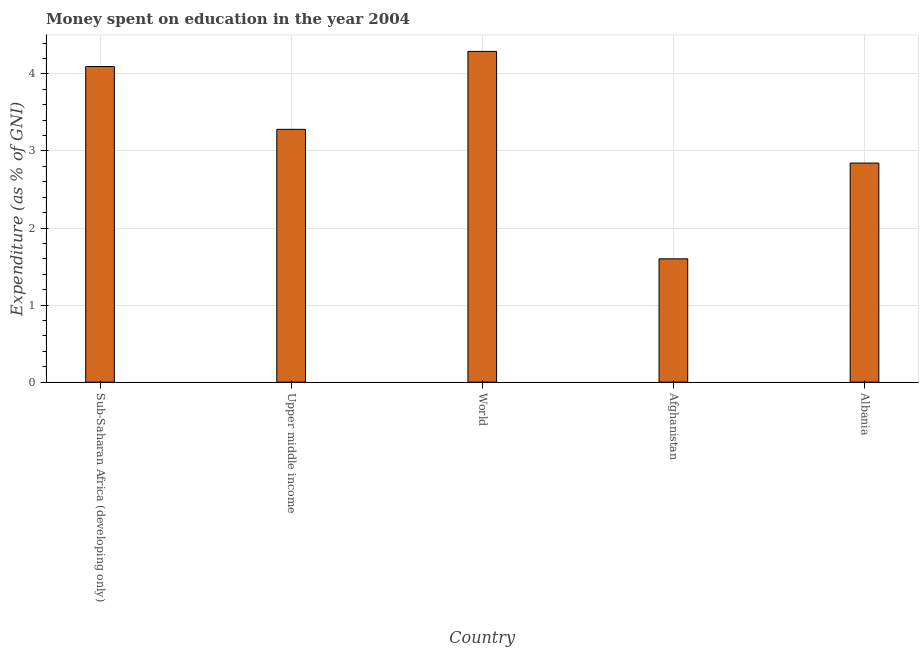What is the title of the graph?
Provide a short and direct response. Money spent on education in the year 2004. What is the label or title of the Y-axis?
Provide a short and direct response. Expenditure (as % of GNI). What is the expenditure on education in Upper middle income?
Give a very brief answer. 3.28. Across all countries, what is the maximum expenditure on education?
Provide a short and direct response. 4.29. In which country was the expenditure on education maximum?
Make the answer very short. World. In which country was the expenditure on education minimum?
Offer a very short reply. Afghanistan. What is the sum of the expenditure on education?
Keep it short and to the point. 16.11. What is the difference between the expenditure on education in Albania and Upper middle income?
Provide a short and direct response. -0.44. What is the average expenditure on education per country?
Your response must be concise. 3.22. What is the median expenditure on education?
Offer a terse response. 3.28. What is the ratio of the expenditure on education in Albania to that in World?
Offer a terse response. 0.66. Is the expenditure on education in Afghanistan less than that in Upper middle income?
Give a very brief answer. Yes. What is the difference between the highest and the second highest expenditure on education?
Make the answer very short. 0.2. Is the sum of the expenditure on education in Albania and Sub-Saharan Africa (developing only) greater than the maximum expenditure on education across all countries?
Make the answer very short. Yes. What is the difference between the highest and the lowest expenditure on education?
Keep it short and to the point. 2.69. In how many countries, is the expenditure on education greater than the average expenditure on education taken over all countries?
Your answer should be compact. 3. How many bars are there?
Your answer should be compact. 5. Are all the bars in the graph horizontal?
Give a very brief answer. No. Are the values on the major ticks of Y-axis written in scientific E-notation?
Provide a short and direct response. No. What is the Expenditure (as % of GNI) of Sub-Saharan Africa (developing only)?
Your answer should be very brief. 4.1. What is the Expenditure (as % of GNI) of Upper middle income?
Offer a terse response. 3.28. What is the Expenditure (as % of GNI) of World?
Make the answer very short. 4.29. What is the Expenditure (as % of GNI) of Albania?
Offer a very short reply. 2.84. What is the difference between the Expenditure (as % of GNI) in Sub-Saharan Africa (developing only) and Upper middle income?
Provide a short and direct response. 0.82. What is the difference between the Expenditure (as % of GNI) in Sub-Saharan Africa (developing only) and World?
Your answer should be compact. -0.2. What is the difference between the Expenditure (as % of GNI) in Sub-Saharan Africa (developing only) and Afghanistan?
Offer a very short reply. 2.5. What is the difference between the Expenditure (as % of GNI) in Sub-Saharan Africa (developing only) and Albania?
Provide a short and direct response. 1.25. What is the difference between the Expenditure (as % of GNI) in Upper middle income and World?
Your response must be concise. -1.01. What is the difference between the Expenditure (as % of GNI) in Upper middle income and Afghanistan?
Provide a short and direct response. 1.68. What is the difference between the Expenditure (as % of GNI) in Upper middle income and Albania?
Keep it short and to the point. 0.44. What is the difference between the Expenditure (as % of GNI) in World and Afghanistan?
Give a very brief answer. 2.69. What is the difference between the Expenditure (as % of GNI) in World and Albania?
Give a very brief answer. 1.45. What is the difference between the Expenditure (as % of GNI) in Afghanistan and Albania?
Give a very brief answer. -1.24. What is the ratio of the Expenditure (as % of GNI) in Sub-Saharan Africa (developing only) to that in Upper middle income?
Your response must be concise. 1.25. What is the ratio of the Expenditure (as % of GNI) in Sub-Saharan Africa (developing only) to that in World?
Your answer should be compact. 0.95. What is the ratio of the Expenditure (as % of GNI) in Sub-Saharan Africa (developing only) to that in Afghanistan?
Give a very brief answer. 2.56. What is the ratio of the Expenditure (as % of GNI) in Sub-Saharan Africa (developing only) to that in Albania?
Your response must be concise. 1.44. What is the ratio of the Expenditure (as % of GNI) in Upper middle income to that in World?
Make the answer very short. 0.76. What is the ratio of the Expenditure (as % of GNI) in Upper middle income to that in Afghanistan?
Make the answer very short. 2.05. What is the ratio of the Expenditure (as % of GNI) in Upper middle income to that in Albania?
Ensure brevity in your answer.  1.15. What is the ratio of the Expenditure (as % of GNI) in World to that in Afghanistan?
Your answer should be compact. 2.68. What is the ratio of the Expenditure (as % of GNI) in World to that in Albania?
Offer a very short reply. 1.51. What is the ratio of the Expenditure (as % of GNI) in Afghanistan to that in Albania?
Offer a very short reply. 0.56. 